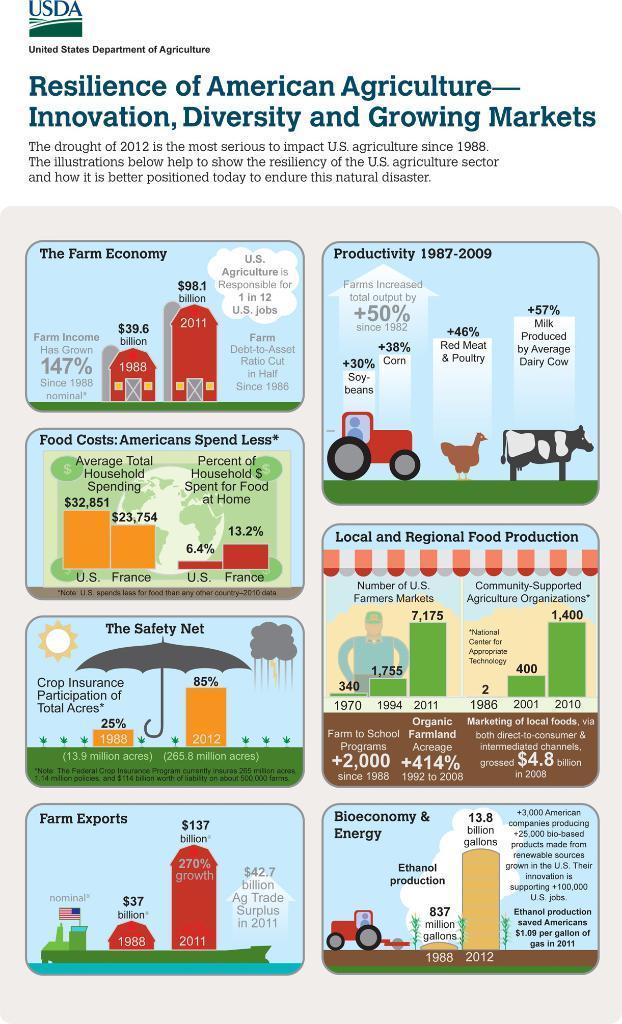Please provide a concise description of this image. In this picture we can see a page, there is some text at the top of the image, we can see images of an umbrella, a car, a cow, a person here, there are some numbers. 